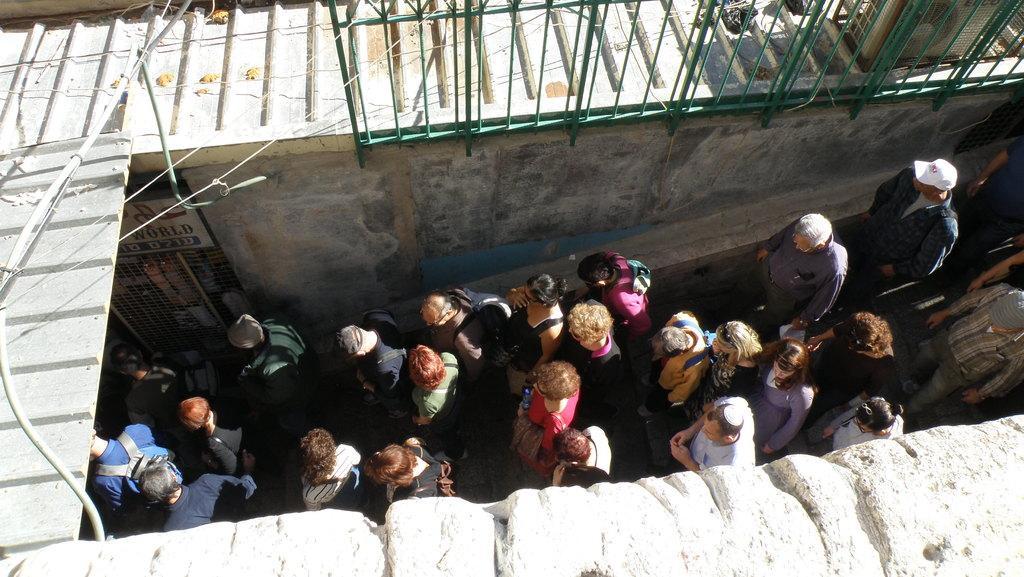In one or two sentences, can you explain what this image depicts? This is an outside view. In the middle of the image I can see a crowd of people walking towards the left side. At the bottom and top of the image I can see the walls and few metal objects. 